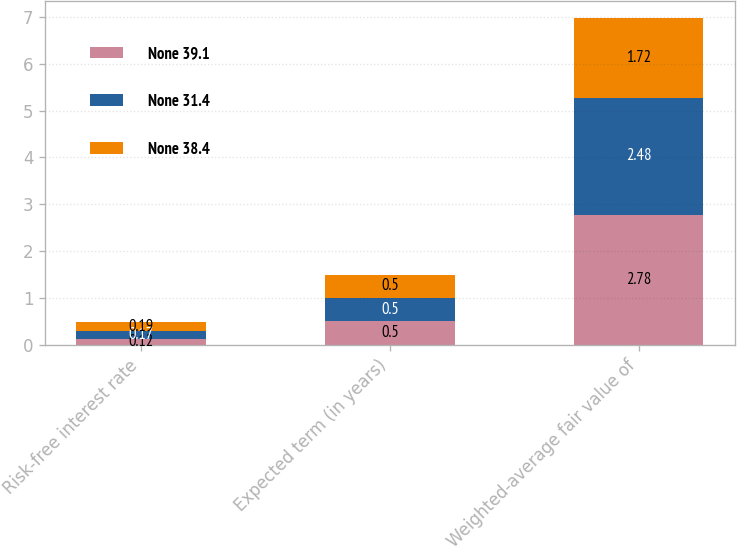Convert chart. <chart><loc_0><loc_0><loc_500><loc_500><stacked_bar_chart><ecel><fcel>Risk-free interest rate<fcel>Expected term (in years)<fcel>Weighted-average fair value of<nl><fcel>None 39.1<fcel>0.12<fcel>0.5<fcel>2.78<nl><fcel>None 31.4<fcel>0.17<fcel>0.5<fcel>2.48<nl><fcel>None 38.4<fcel>0.19<fcel>0.5<fcel>1.72<nl></chart> 